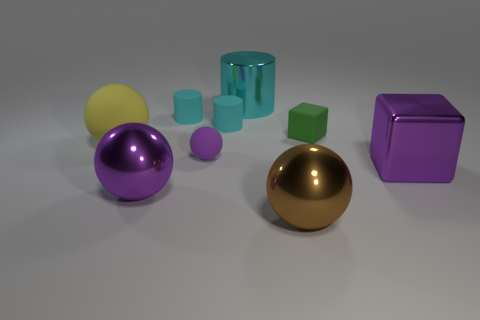Subtract all yellow spheres. How many spheres are left? 3 Subtract all large shiny cylinders. How many cylinders are left? 2 Add 3 yellow rubber spheres. How many yellow rubber spheres exist? 4 Add 1 cyan matte cylinders. How many objects exist? 10 Subtract 0 green cylinders. How many objects are left? 9 Subtract all spheres. How many objects are left? 5 Subtract 1 cylinders. How many cylinders are left? 2 Subtract all purple cylinders. Subtract all brown cubes. How many cylinders are left? 3 Subtract all gray cubes. How many brown spheres are left? 1 Subtract all tiny blue shiny objects. Subtract all green rubber blocks. How many objects are left? 8 